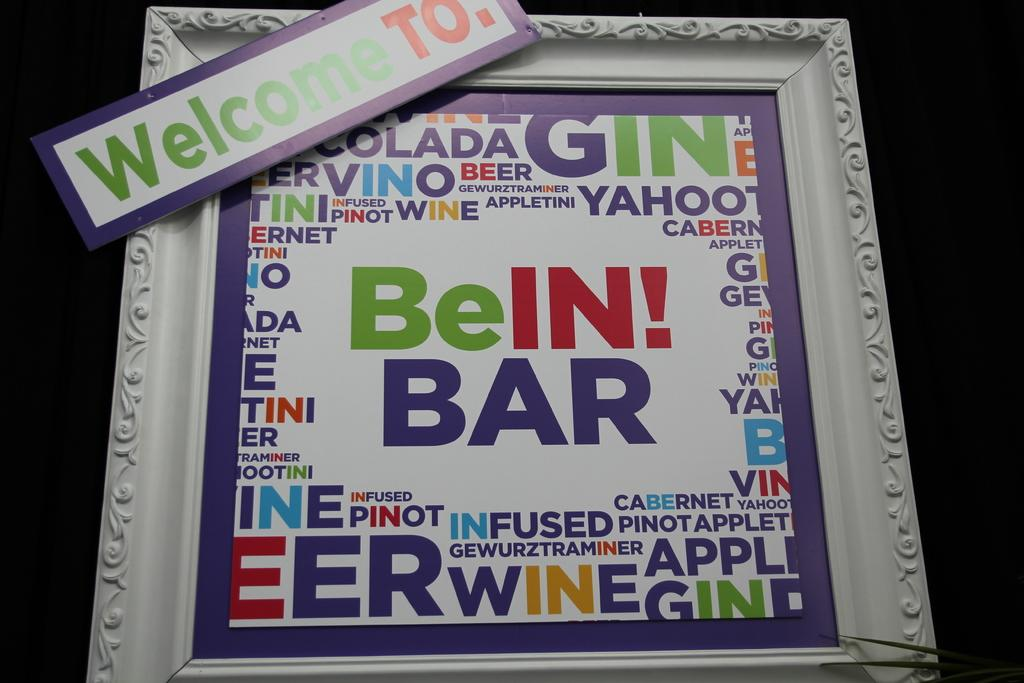Provide a one-sentence caption for the provided image. A white picture frame  with a banner on it that says Welcome to on it. 